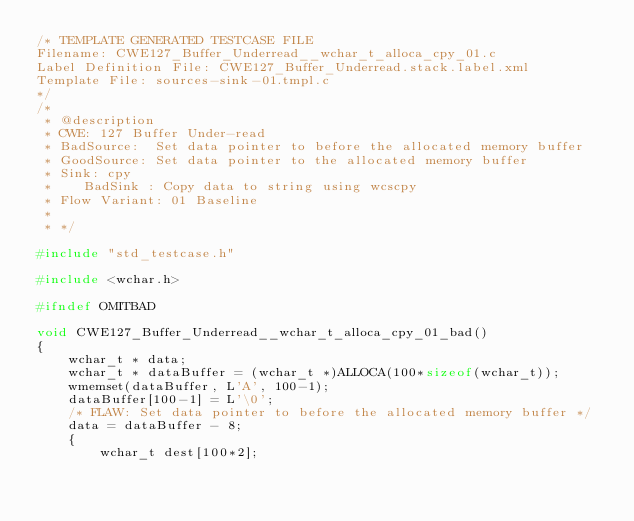<code> <loc_0><loc_0><loc_500><loc_500><_C_>/* TEMPLATE GENERATED TESTCASE FILE
Filename: CWE127_Buffer_Underread__wchar_t_alloca_cpy_01.c
Label Definition File: CWE127_Buffer_Underread.stack.label.xml
Template File: sources-sink-01.tmpl.c
*/
/*
 * @description
 * CWE: 127 Buffer Under-read
 * BadSource:  Set data pointer to before the allocated memory buffer
 * GoodSource: Set data pointer to the allocated memory buffer
 * Sink: cpy
 *    BadSink : Copy data to string using wcscpy
 * Flow Variant: 01 Baseline
 *
 * */

#include "std_testcase.h"

#include <wchar.h>

#ifndef OMITBAD

void CWE127_Buffer_Underread__wchar_t_alloca_cpy_01_bad()
{
    wchar_t * data;
    wchar_t * dataBuffer = (wchar_t *)ALLOCA(100*sizeof(wchar_t));
    wmemset(dataBuffer, L'A', 100-1);
    dataBuffer[100-1] = L'\0';
    /* FLAW: Set data pointer to before the allocated memory buffer */
    data = dataBuffer - 8;
    {
        wchar_t dest[100*2];</code> 